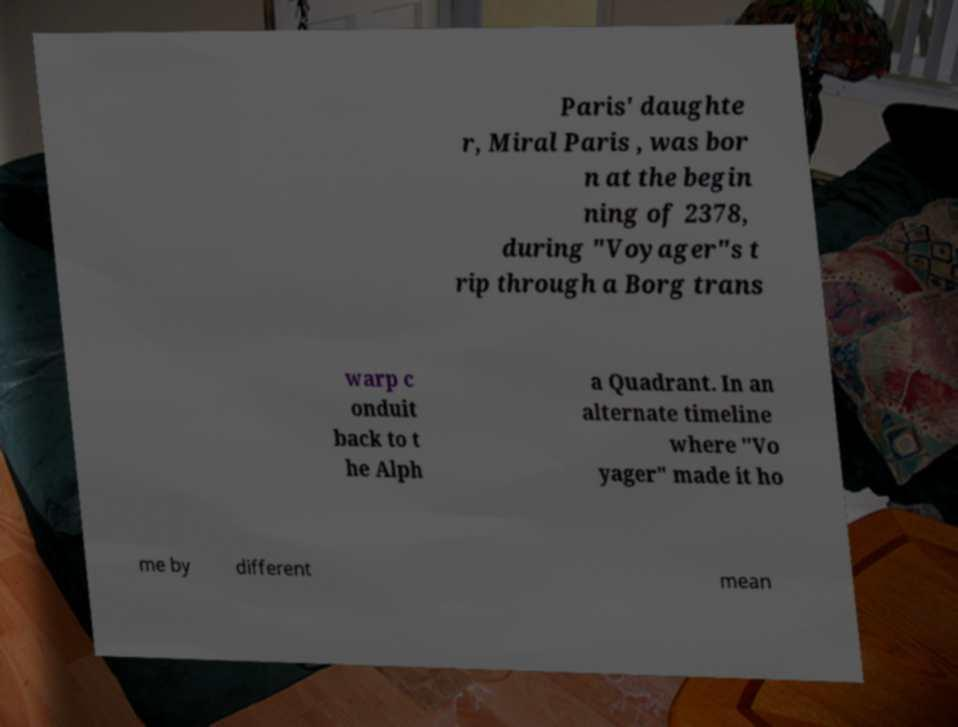Please identify and transcribe the text found in this image. Paris' daughte r, Miral Paris , was bor n at the begin ning of 2378, during "Voyager"s t rip through a Borg trans warp c onduit back to t he Alph a Quadrant. In an alternate timeline where "Vo yager" made it ho me by different mean 